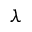Convert formula to latex. <formula><loc_0><loc_0><loc_500><loc_500>\lambda</formula> 